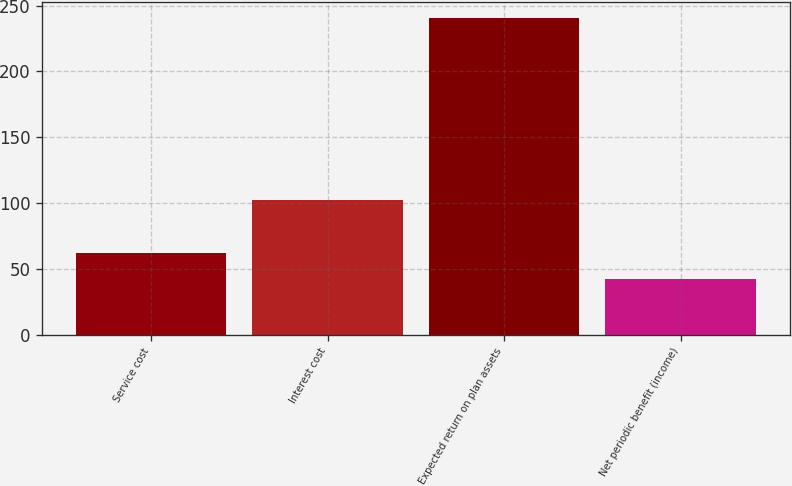<chart> <loc_0><loc_0><loc_500><loc_500><bar_chart><fcel>Service cost<fcel>Interest cost<fcel>Expected return on plan assets<fcel>Net periodic benefit (income)<nl><fcel>61.9<fcel>102<fcel>241<fcel>42<nl></chart> 